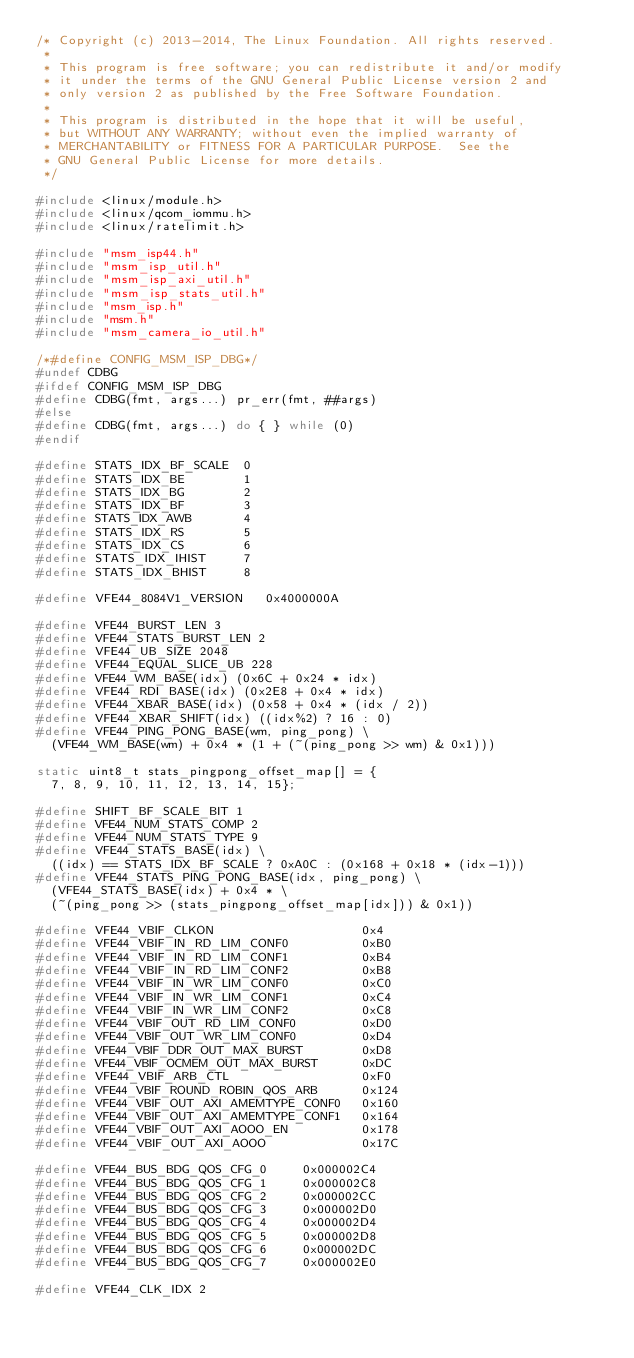<code> <loc_0><loc_0><loc_500><loc_500><_C_>/* Copyright (c) 2013-2014, The Linux Foundation. All rights reserved.
 *
 * This program is free software; you can redistribute it and/or modify
 * it under the terms of the GNU General Public License version 2 and
 * only version 2 as published by the Free Software Foundation.
 *
 * This program is distributed in the hope that it will be useful,
 * but WITHOUT ANY WARRANTY; without even the implied warranty of
 * MERCHANTABILITY or FITNESS FOR A PARTICULAR PURPOSE.  See the
 * GNU General Public License for more details.
 */

#include <linux/module.h>
#include <linux/qcom_iommu.h>
#include <linux/ratelimit.h>

#include "msm_isp44.h"
#include "msm_isp_util.h"
#include "msm_isp_axi_util.h"
#include "msm_isp_stats_util.h"
#include "msm_isp.h"
#include "msm.h"
#include "msm_camera_io_util.h"

/*#define CONFIG_MSM_ISP_DBG*/
#undef CDBG
#ifdef CONFIG_MSM_ISP_DBG
#define CDBG(fmt, args...) pr_err(fmt, ##args)
#else
#define CDBG(fmt, args...) do { } while (0)
#endif

#define STATS_IDX_BF_SCALE  0
#define STATS_IDX_BE        1
#define STATS_IDX_BG        2
#define STATS_IDX_BF        3
#define STATS_IDX_AWB       4
#define STATS_IDX_RS        5
#define STATS_IDX_CS        6
#define STATS_IDX_IHIST     7
#define STATS_IDX_BHIST     8

#define VFE44_8084V1_VERSION   0x4000000A

#define VFE44_BURST_LEN 3
#define VFE44_STATS_BURST_LEN 2
#define VFE44_UB_SIZE 2048
#define VFE44_EQUAL_SLICE_UB 228
#define VFE44_WM_BASE(idx) (0x6C + 0x24 * idx)
#define VFE44_RDI_BASE(idx) (0x2E8 + 0x4 * idx)
#define VFE44_XBAR_BASE(idx) (0x58 + 0x4 * (idx / 2))
#define VFE44_XBAR_SHIFT(idx) ((idx%2) ? 16 : 0)
#define VFE44_PING_PONG_BASE(wm, ping_pong) \
	(VFE44_WM_BASE(wm) + 0x4 * (1 + (~(ping_pong >> wm) & 0x1)))

static uint8_t stats_pingpong_offset_map[] = {
	7, 8, 9, 10, 11, 12, 13, 14, 15};

#define SHIFT_BF_SCALE_BIT 1
#define VFE44_NUM_STATS_COMP 2
#define VFE44_NUM_STATS_TYPE 9
#define VFE44_STATS_BASE(idx) \
	((idx) == STATS_IDX_BF_SCALE ? 0xA0C : (0x168 + 0x18 * (idx-1)))
#define VFE44_STATS_PING_PONG_BASE(idx, ping_pong) \
	(VFE44_STATS_BASE(idx) + 0x4 * \
	(~(ping_pong >> (stats_pingpong_offset_map[idx])) & 0x1))

#define VFE44_VBIF_CLKON                    0x4
#define VFE44_VBIF_IN_RD_LIM_CONF0          0xB0
#define VFE44_VBIF_IN_RD_LIM_CONF1          0xB4
#define VFE44_VBIF_IN_RD_LIM_CONF2          0xB8
#define VFE44_VBIF_IN_WR_LIM_CONF0          0xC0
#define VFE44_VBIF_IN_WR_LIM_CONF1          0xC4
#define VFE44_VBIF_IN_WR_LIM_CONF2          0xC8
#define VFE44_VBIF_OUT_RD_LIM_CONF0         0xD0
#define VFE44_VBIF_OUT_WR_LIM_CONF0         0xD4
#define VFE44_VBIF_DDR_OUT_MAX_BURST        0xD8
#define VFE44_VBIF_OCMEM_OUT_MAX_BURST      0xDC
#define VFE44_VBIF_ARB_CTL                  0xF0
#define VFE44_VBIF_ROUND_ROBIN_QOS_ARB      0x124
#define VFE44_VBIF_OUT_AXI_AMEMTYPE_CONF0   0x160
#define VFE44_VBIF_OUT_AXI_AMEMTYPE_CONF1   0x164
#define VFE44_VBIF_OUT_AXI_AOOO_EN          0x178
#define VFE44_VBIF_OUT_AXI_AOOO             0x17C

#define VFE44_BUS_BDG_QOS_CFG_0     0x000002C4
#define VFE44_BUS_BDG_QOS_CFG_1     0x000002C8
#define VFE44_BUS_BDG_QOS_CFG_2     0x000002CC
#define VFE44_BUS_BDG_QOS_CFG_3     0x000002D0
#define VFE44_BUS_BDG_QOS_CFG_4     0x000002D4
#define VFE44_BUS_BDG_QOS_CFG_5     0x000002D8
#define VFE44_BUS_BDG_QOS_CFG_6     0x000002DC
#define VFE44_BUS_BDG_QOS_CFG_7     0x000002E0

#define VFE44_CLK_IDX 2</code> 